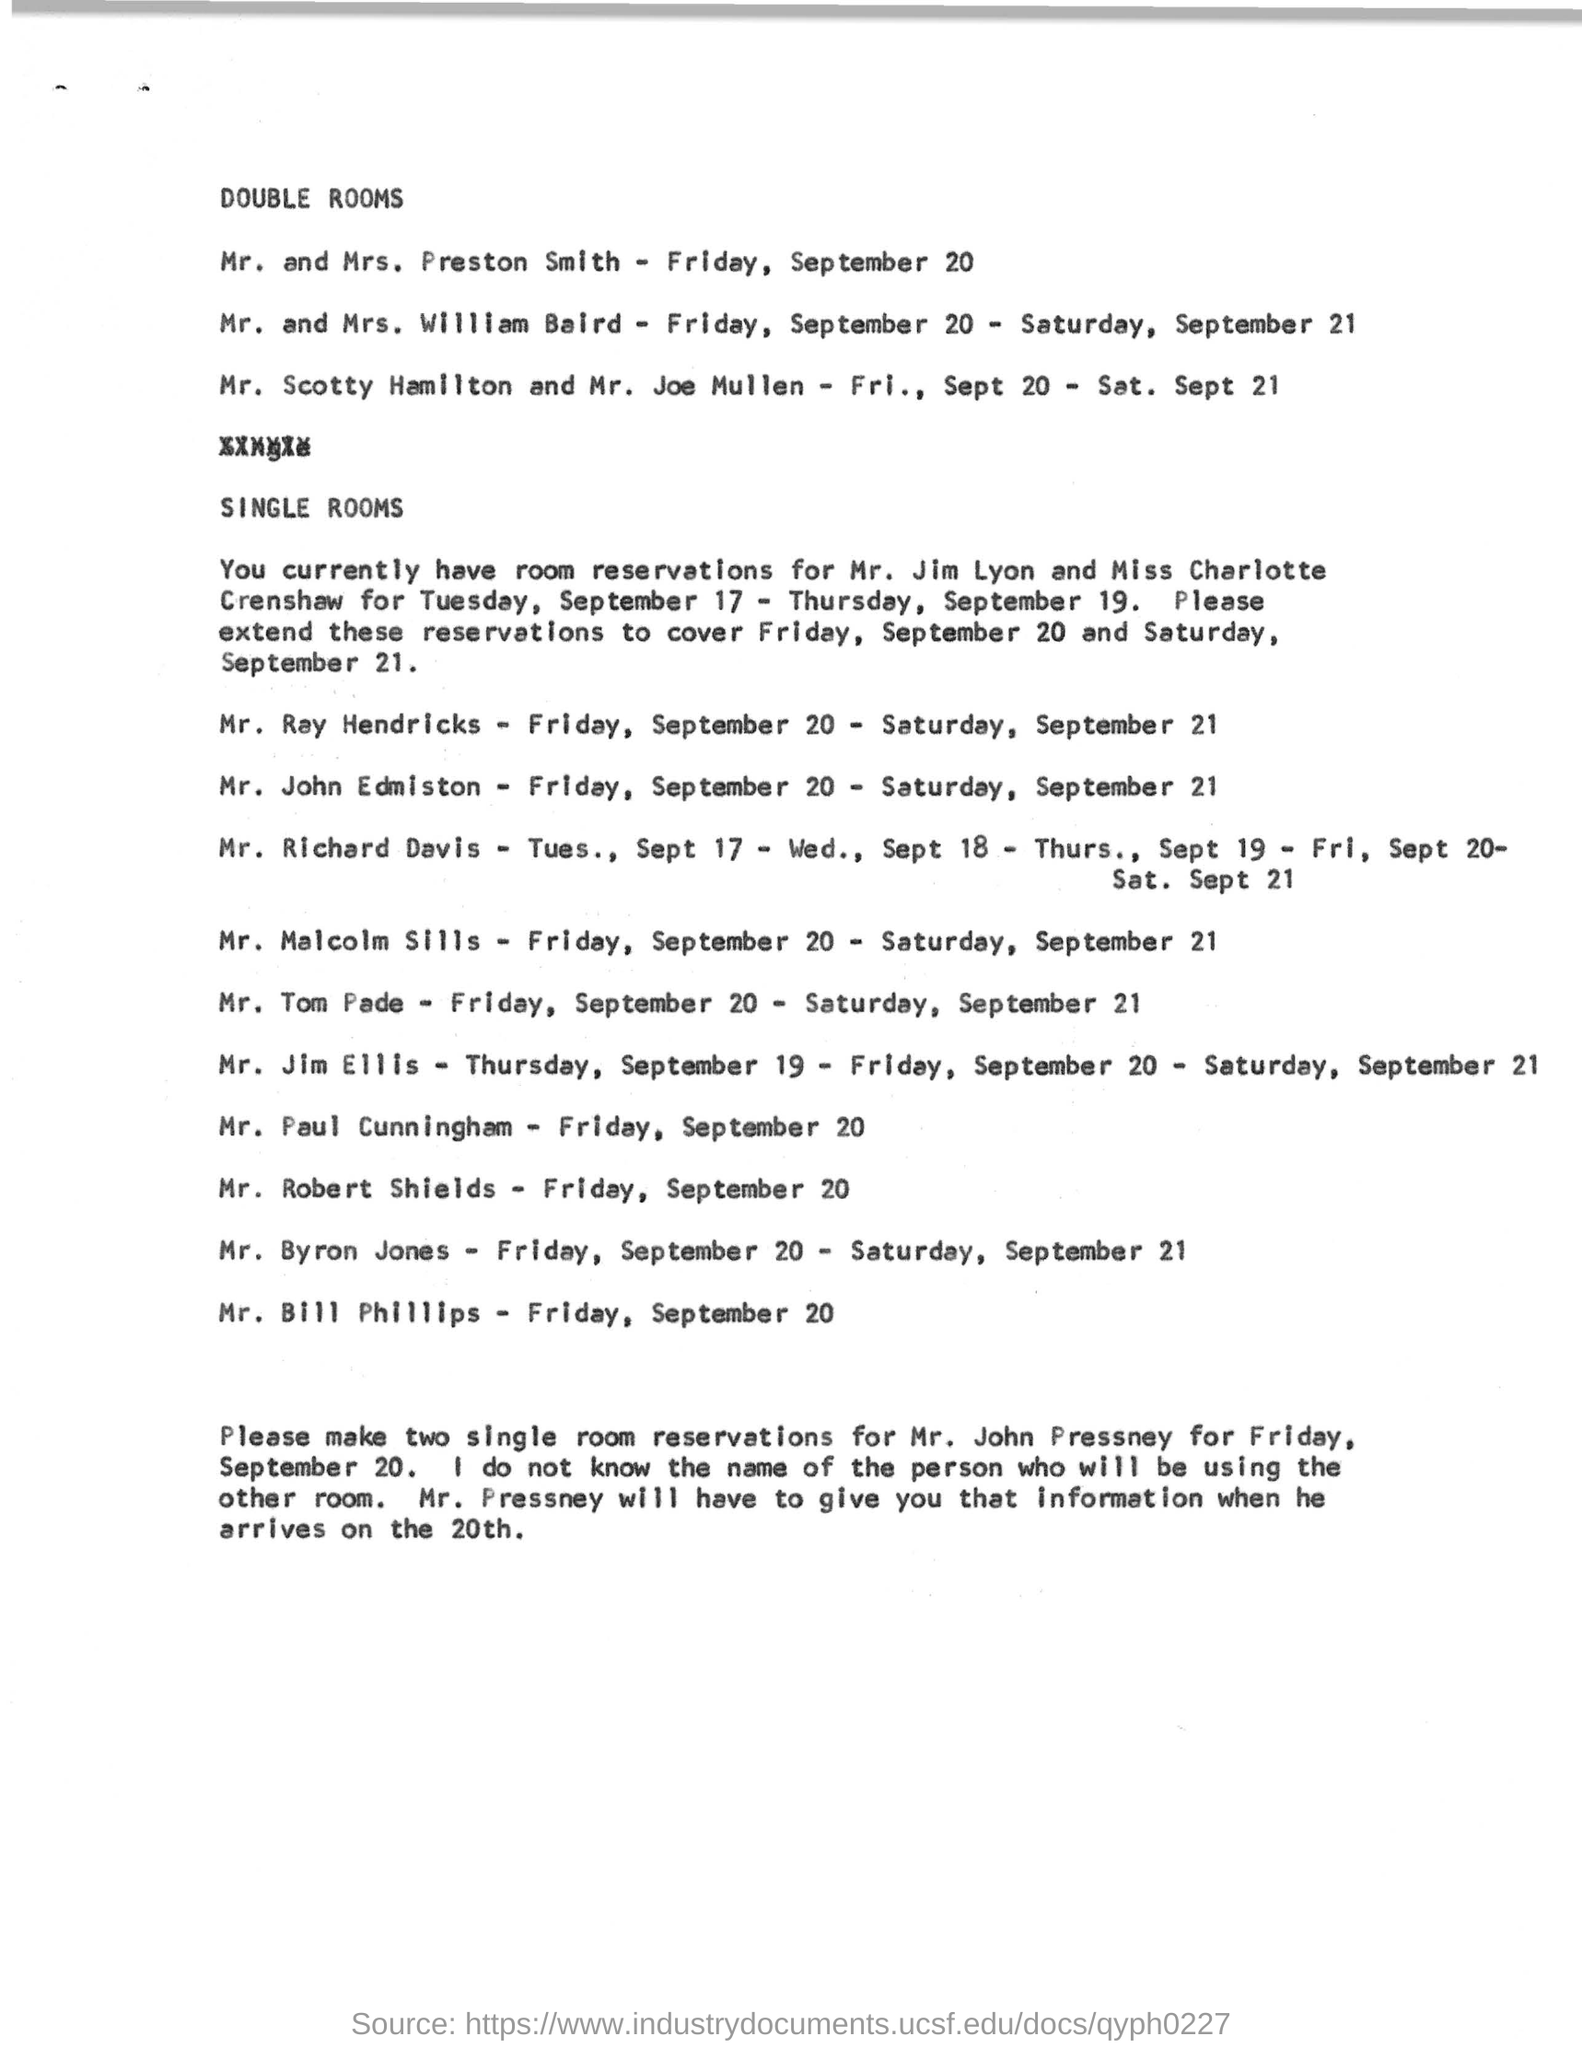In double rooms, who lived on friday ,september 20 ?
Your answer should be compact. Mr. and Mrs. Preston Smith. Mr scotty hamilton and mr. joe mullen lived on which date in double room?
Your answer should be compact. Fri. , Sept 20 - Sat. Sept 21. The current reservations are made for whom?
Your answer should be compact. Mr. Jim Lyon and Miss Charlotte Crenshaw. To whom they have to make single room reservations for friday , september 20 ?
Provide a succinct answer. Mr.  John Pressney. 